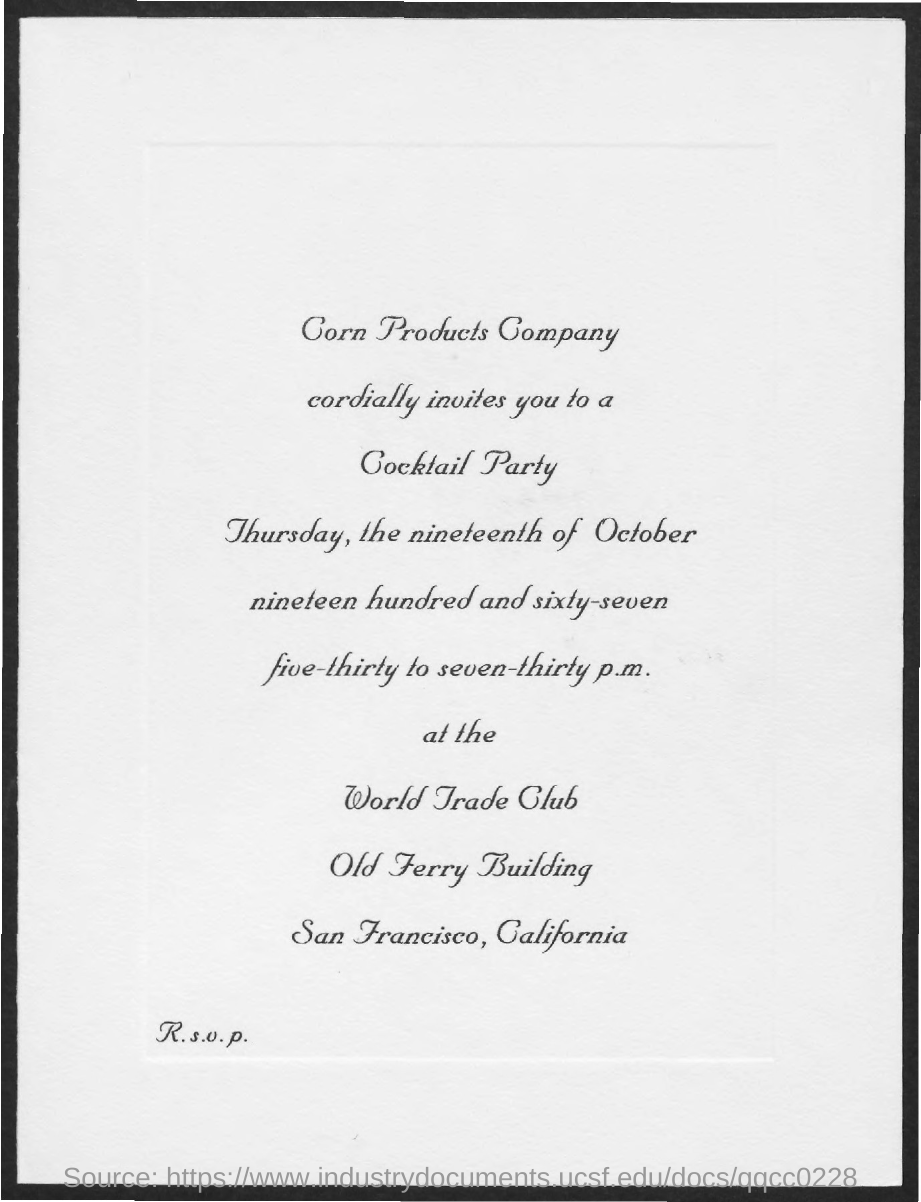What is the Invitation for?
Make the answer very short. COCKTAIL PARTY. 